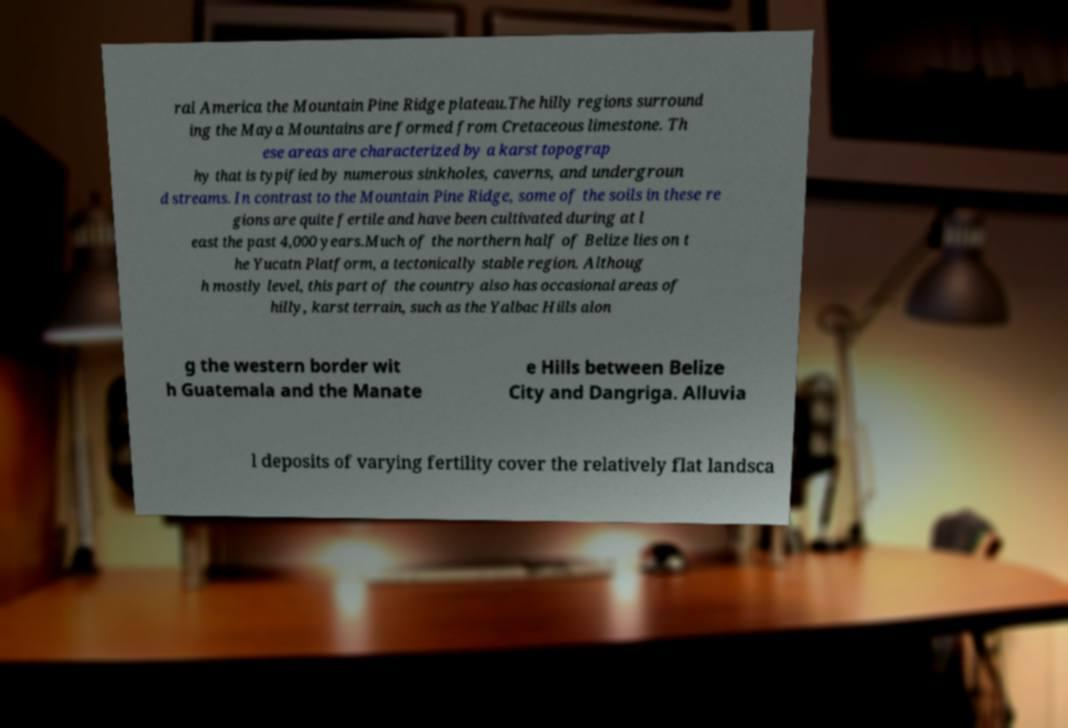I need the written content from this picture converted into text. Can you do that? ral America the Mountain Pine Ridge plateau.The hilly regions surround ing the Maya Mountains are formed from Cretaceous limestone. Th ese areas are characterized by a karst topograp hy that is typified by numerous sinkholes, caverns, and undergroun d streams. In contrast to the Mountain Pine Ridge, some of the soils in these re gions are quite fertile and have been cultivated during at l east the past 4,000 years.Much of the northern half of Belize lies on t he Yucatn Platform, a tectonically stable region. Althoug h mostly level, this part of the country also has occasional areas of hilly, karst terrain, such as the Yalbac Hills alon g the western border wit h Guatemala and the Manate e Hills between Belize City and Dangriga. Alluvia l deposits of varying fertility cover the relatively flat landsca 